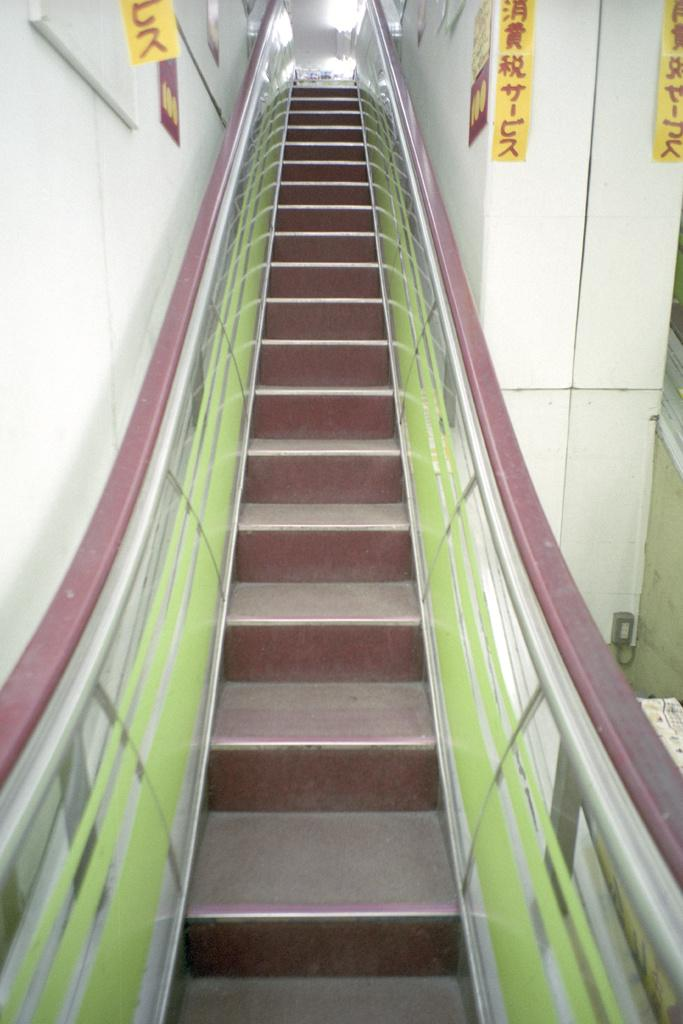What type of architectural feature is present in the image? There are steps in the image. What surrounds the steps in the image? There is a wall on either side of the steps. What type of linen is draped over the steps in the image? There is no linen present in the image; the steps are not covered or draped with any fabric. 